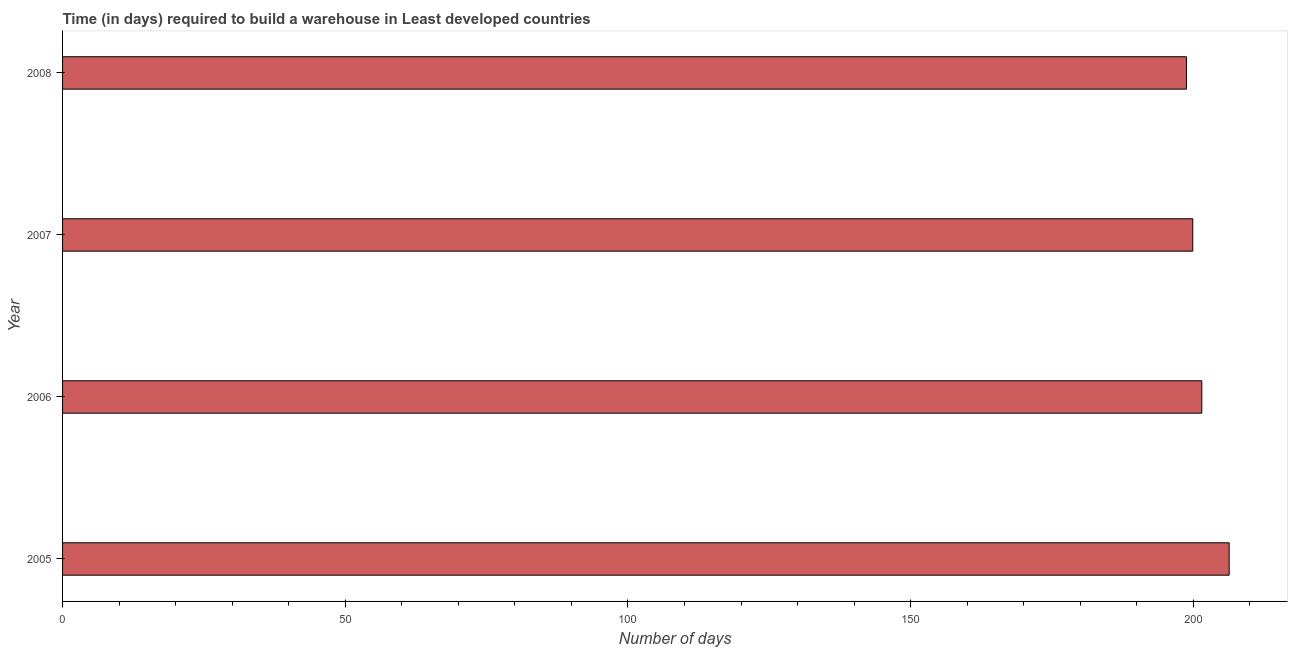Does the graph contain any zero values?
Offer a terse response. No. Does the graph contain grids?
Your response must be concise. No. What is the title of the graph?
Keep it short and to the point. Time (in days) required to build a warehouse in Least developed countries. What is the label or title of the X-axis?
Provide a short and direct response. Number of days. What is the time required to build a warehouse in 2005?
Provide a succinct answer. 206.34. Across all years, what is the maximum time required to build a warehouse?
Make the answer very short. 206.34. Across all years, what is the minimum time required to build a warehouse?
Your answer should be very brief. 198.79. In which year was the time required to build a warehouse maximum?
Your answer should be very brief. 2005. What is the sum of the time required to build a warehouse?
Ensure brevity in your answer.  806.53. What is the difference between the time required to build a warehouse in 2005 and 2006?
Your answer should be very brief. 4.84. What is the average time required to build a warehouse per year?
Ensure brevity in your answer.  201.63. What is the median time required to build a warehouse?
Your response must be concise. 200.7. In how many years, is the time required to build a warehouse greater than 20 days?
Offer a very short reply. 4. Is the difference between the time required to build a warehouse in 2006 and 2007 greater than the difference between any two years?
Make the answer very short. No. What is the difference between the highest and the second highest time required to build a warehouse?
Your response must be concise. 4.84. What is the difference between the highest and the lowest time required to build a warehouse?
Give a very brief answer. 7.56. How many bars are there?
Keep it short and to the point. 4. Are all the bars in the graph horizontal?
Offer a very short reply. Yes. How many years are there in the graph?
Your response must be concise. 4. Are the values on the major ticks of X-axis written in scientific E-notation?
Offer a very short reply. No. What is the Number of days in 2005?
Keep it short and to the point. 206.34. What is the Number of days of 2006?
Provide a short and direct response. 201.5. What is the Number of days in 2007?
Give a very brief answer. 199.9. What is the Number of days in 2008?
Give a very brief answer. 198.79. What is the difference between the Number of days in 2005 and 2006?
Your response must be concise. 4.84. What is the difference between the Number of days in 2005 and 2007?
Ensure brevity in your answer.  6.44. What is the difference between the Number of days in 2005 and 2008?
Your answer should be compact. 7.56. What is the difference between the Number of days in 2006 and 2007?
Your answer should be very brief. 1.6. What is the difference between the Number of days in 2006 and 2008?
Provide a succinct answer. 2.71. What is the difference between the Number of days in 2007 and 2008?
Offer a terse response. 1.12. What is the ratio of the Number of days in 2005 to that in 2006?
Keep it short and to the point. 1.02. What is the ratio of the Number of days in 2005 to that in 2007?
Ensure brevity in your answer.  1.03. What is the ratio of the Number of days in 2005 to that in 2008?
Offer a terse response. 1.04. What is the ratio of the Number of days in 2006 to that in 2007?
Your answer should be very brief. 1.01. What is the ratio of the Number of days in 2006 to that in 2008?
Provide a succinct answer. 1.01. What is the ratio of the Number of days in 2007 to that in 2008?
Offer a very short reply. 1.01. 